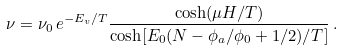Convert formula to latex. <formula><loc_0><loc_0><loc_500><loc_500>\nu = \nu _ { 0 } \, e ^ { - E _ { v } / T } \frac { \cosh ( \mu H / T ) } { \cosh [ E _ { 0 } ( N - \phi _ { a } / \phi _ { 0 } + 1 / 2 ) / T ] } \, .</formula> 